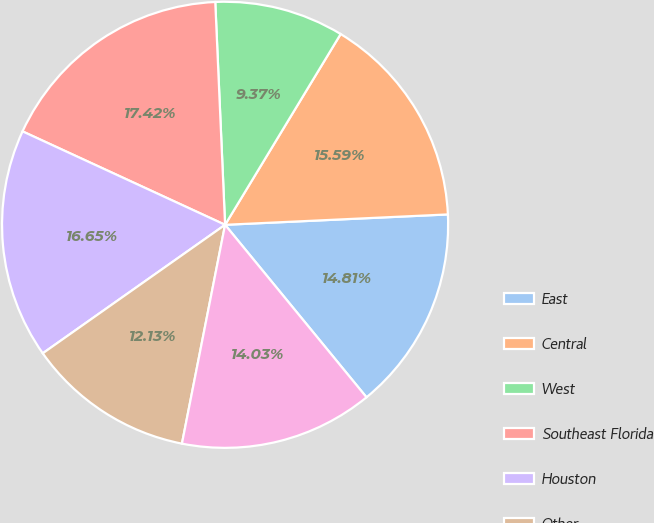Convert chart to OTSL. <chart><loc_0><loc_0><loc_500><loc_500><pie_chart><fcel>East<fcel>Central<fcel>West<fcel>Southeast Florida<fcel>Houston<fcel>Other<fcel>Total<nl><fcel>14.81%<fcel>15.59%<fcel>9.37%<fcel>17.42%<fcel>16.65%<fcel>12.13%<fcel>14.03%<nl></chart> 